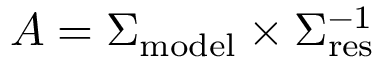Convert formula to latex. <formula><loc_0><loc_0><loc_500><loc_500>A = \Sigma _ { m o d e l } \times \Sigma _ { r e s } ^ { - 1 }</formula> 